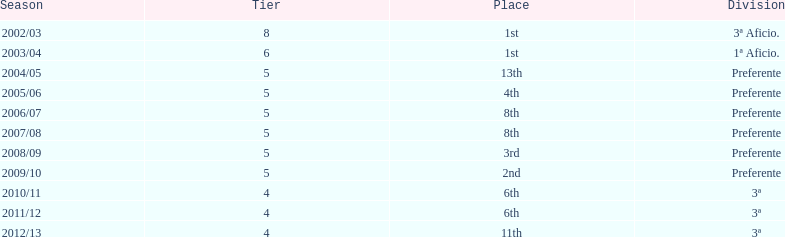What place was 1a aficio and 3a aficio? 1st. 